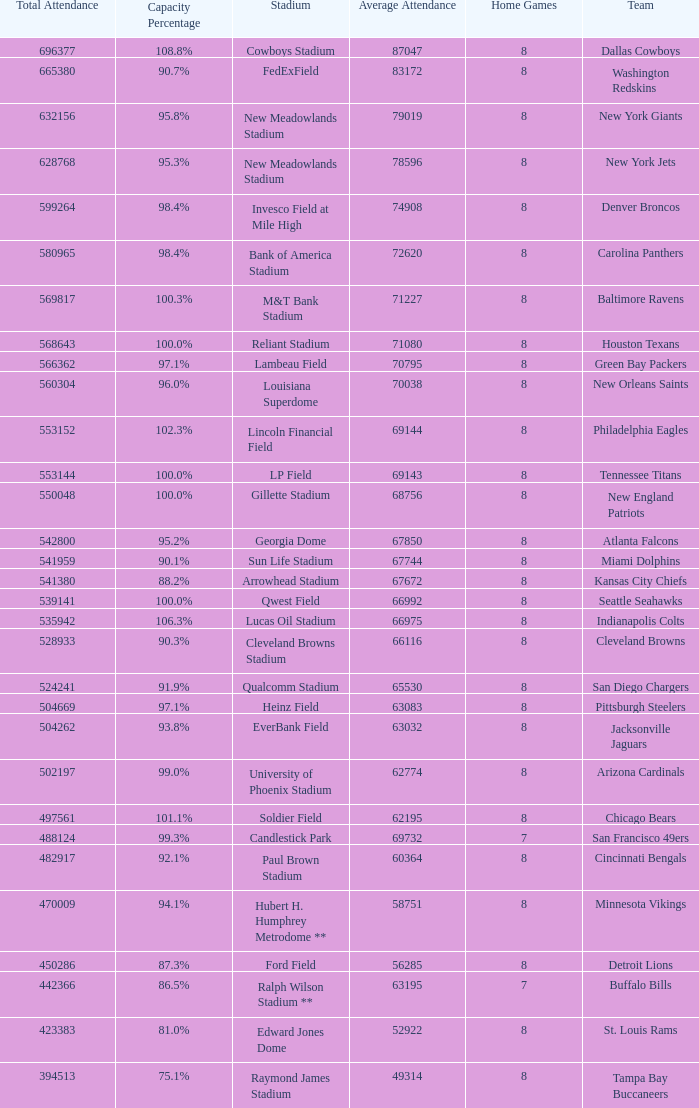What was the capacity for the Denver Broncos? 98.4%. Write the full table. {'header': ['Total Attendance', 'Capacity Percentage', 'Stadium', 'Average Attendance', 'Home Games', 'Team'], 'rows': [['696377', '108.8%', 'Cowboys Stadium', '87047', '8', 'Dallas Cowboys'], ['665380', '90.7%', 'FedExField', '83172', '8', 'Washington Redskins'], ['632156', '95.8%', 'New Meadowlands Stadium', '79019', '8', 'New York Giants'], ['628768', '95.3%', 'New Meadowlands Stadium', '78596', '8', 'New York Jets'], ['599264', '98.4%', 'Invesco Field at Mile High', '74908', '8', 'Denver Broncos'], ['580965', '98.4%', 'Bank of America Stadium', '72620', '8', 'Carolina Panthers'], ['569817', '100.3%', 'M&T Bank Stadium', '71227', '8', 'Baltimore Ravens'], ['568643', '100.0%', 'Reliant Stadium', '71080', '8', 'Houston Texans'], ['566362', '97.1%', 'Lambeau Field', '70795', '8', 'Green Bay Packers'], ['560304', '96.0%', 'Louisiana Superdome', '70038', '8', 'New Orleans Saints'], ['553152', '102.3%', 'Lincoln Financial Field', '69144', '8', 'Philadelphia Eagles'], ['553144', '100.0%', 'LP Field', '69143', '8', 'Tennessee Titans'], ['550048', '100.0%', 'Gillette Stadium', '68756', '8', 'New England Patriots'], ['542800', '95.2%', 'Georgia Dome', '67850', '8', 'Atlanta Falcons'], ['541959', '90.1%', 'Sun Life Stadium', '67744', '8', 'Miami Dolphins'], ['541380', '88.2%', 'Arrowhead Stadium', '67672', '8', 'Kansas City Chiefs'], ['539141', '100.0%', 'Qwest Field', '66992', '8', 'Seattle Seahawks'], ['535942', '106.3%', 'Lucas Oil Stadium', '66975', '8', 'Indianapolis Colts'], ['528933', '90.3%', 'Cleveland Browns Stadium', '66116', '8', 'Cleveland Browns'], ['524241', '91.9%', 'Qualcomm Stadium', '65530', '8', 'San Diego Chargers'], ['504669', '97.1%', 'Heinz Field', '63083', '8', 'Pittsburgh Steelers'], ['504262', '93.8%', 'EverBank Field', '63032', '8', 'Jacksonville Jaguars'], ['502197', '99.0%', 'University of Phoenix Stadium', '62774', '8', 'Arizona Cardinals'], ['497561', '101.1%', 'Soldier Field', '62195', '8', 'Chicago Bears'], ['488124', '99.3%', 'Candlestick Park', '69732', '7', 'San Francisco 49ers'], ['482917', '92.1%', 'Paul Brown Stadium', '60364', '8', 'Cincinnati Bengals'], ['470009', '94.1%', 'Hubert H. Humphrey Metrodome **', '58751', '8', 'Minnesota Vikings'], ['450286', '87.3%', 'Ford Field', '56285', '8', 'Detroit Lions'], ['442366', '86.5%', 'Ralph Wilson Stadium **', '63195', '7', 'Buffalo Bills'], ['423383', '81.0%', 'Edward Jones Dome', '52922', '8', 'St. Louis Rams'], ['394513', '75.1%', 'Raymond James Stadium', '49314', '8', 'Tampa Bay Buccaneers']]} 